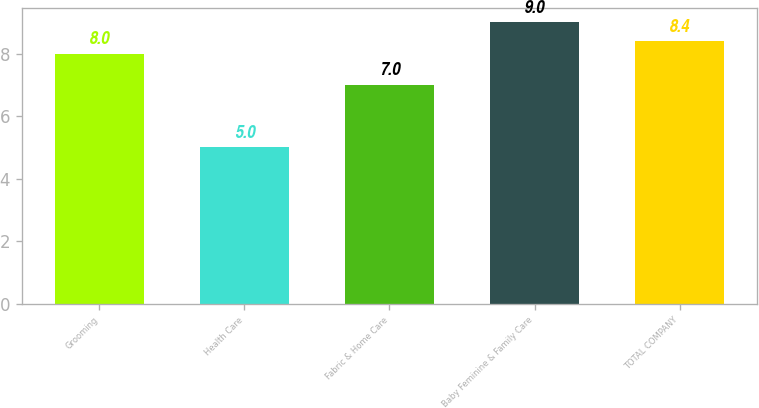Convert chart. <chart><loc_0><loc_0><loc_500><loc_500><bar_chart><fcel>Grooming<fcel>Health Care<fcel>Fabric & Home Care<fcel>Baby Feminine & Family Care<fcel>TOTAL COMPANY<nl><fcel>8<fcel>5<fcel>7<fcel>9<fcel>8.4<nl></chart> 